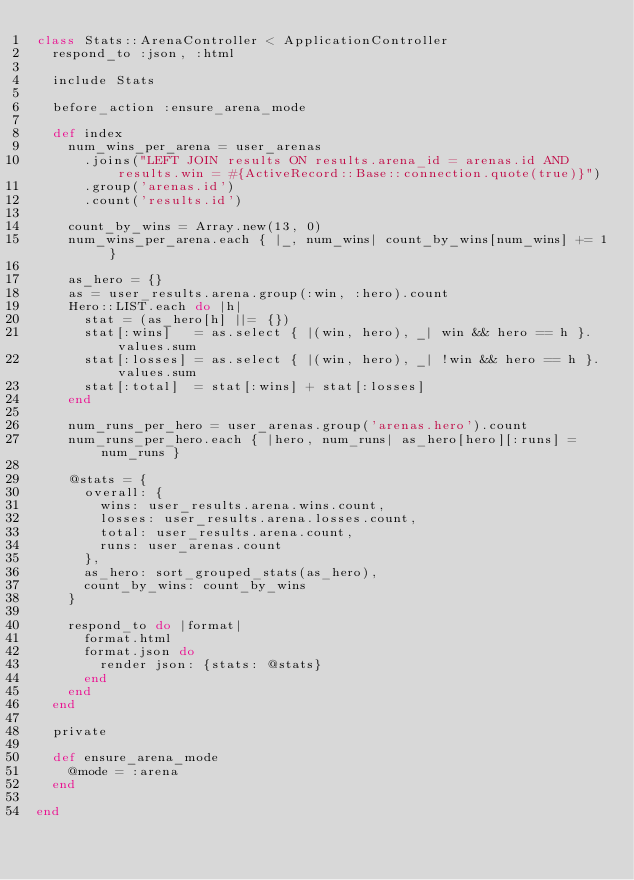<code> <loc_0><loc_0><loc_500><loc_500><_Ruby_>class Stats::ArenaController < ApplicationController
  respond_to :json, :html

  include Stats

  before_action :ensure_arena_mode

  def index
    num_wins_per_arena = user_arenas
      .joins("LEFT JOIN results ON results.arena_id = arenas.id AND results.win = #{ActiveRecord::Base::connection.quote(true)}")
      .group('arenas.id')
      .count('results.id')

    count_by_wins = Array.new(13, 0)
    num_wins_per_arena.each { |_, num_wins| count_by_wins[num_wins] += 1 }

    as_hero = {}
    as = user_results.arena.group(:win, :hero).count
    Hero::LIST.each do |h|
      stat = (as_hero[h] ||= {})
      stat[:wins]   = as.select { |(win, hero), _| win && hero == h }.values.sum
      stat[:losses] = as.select { |(win, hero), _| !win && hero == h }.values.sum
      stat[:total]  = stat[:wins] + stat[:losses]
    end

    num_runs_per_hero = user_arenas.group('arenas.hero').count
    num_runs_per_hero.each { |hero, num_runs| as_hero[hero][:runs] = num_runs }

    @stats = {
      overall: {
        wins: user_results.arena.wins.count,
        losses: user_results.arena.losses.count,
        total: user_results.arena.count,
        runs: user_arenas.count
      },
      as_hero: sort_grouped_stats(as_hero),
      count_by_wins: count_by_wins
    }

    respond_to do |format|
      format.html
      format.json do
        render json: {stats: @stats}
      end
    end
  end

  private

  def ensure_arena_mode
    @mode = :arena
  end

end
</code> 